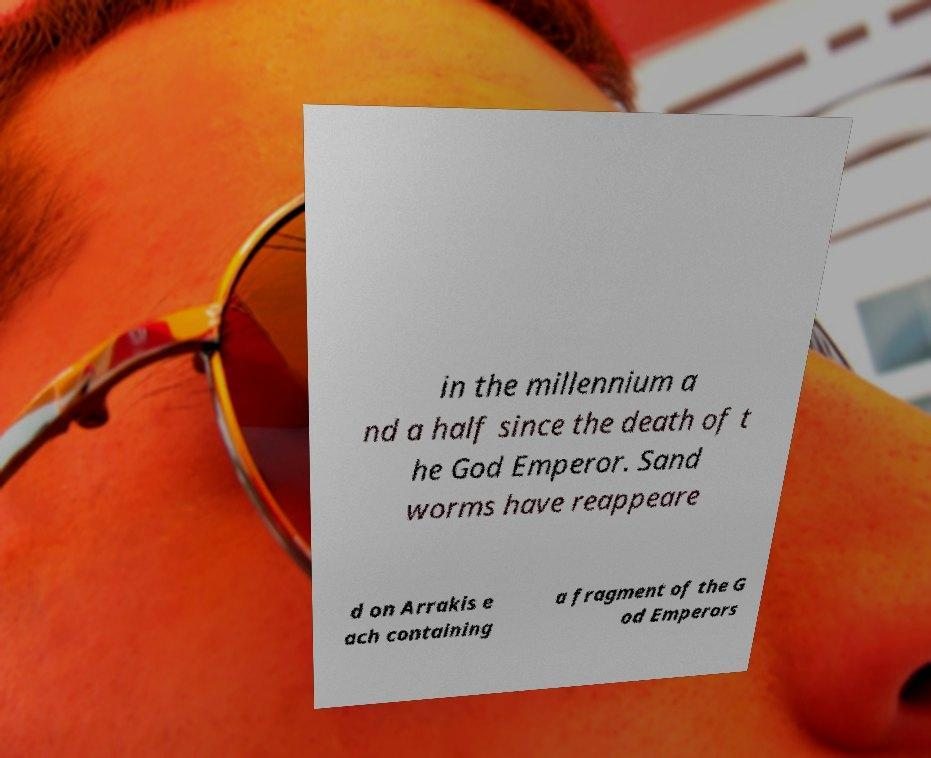There's text embedded in this image that I need extracted. Can you transcribe it verbatim? in the millennium a nd a half since the death of t he God Emperor. Sand worms have reappeare d on Arrakis e ach containing a fragment of the G od Emperors 